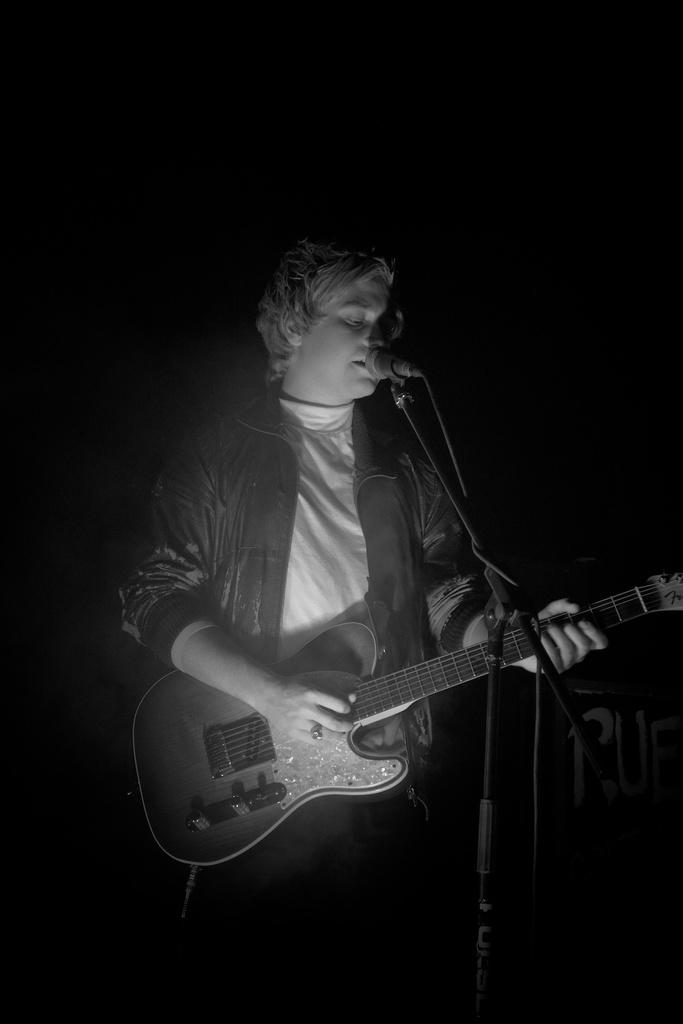What is the man in the image holding? The man is holding a guitar and a microphone. What is the man doing with the guitar? The man is playing the guitar. What is the man doing with the microphone? The man is singing into the microphone. What is the man standing in front of? The man is standing in front of a stand. How many dinner plates are visible in the image? There are no dinner plates visible in the image. What type of stocking is the man wearing in the image? The man is not wearing any stockings in the image. 